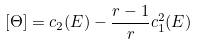<formula> <loc_0><loc_0><loc_500><loc_500>[ \Theta ] = c _ { 2 } ( E ) - \frac { r - 1 } { r } c _ { 1 } ^ { 2 } ( E )</formula> 